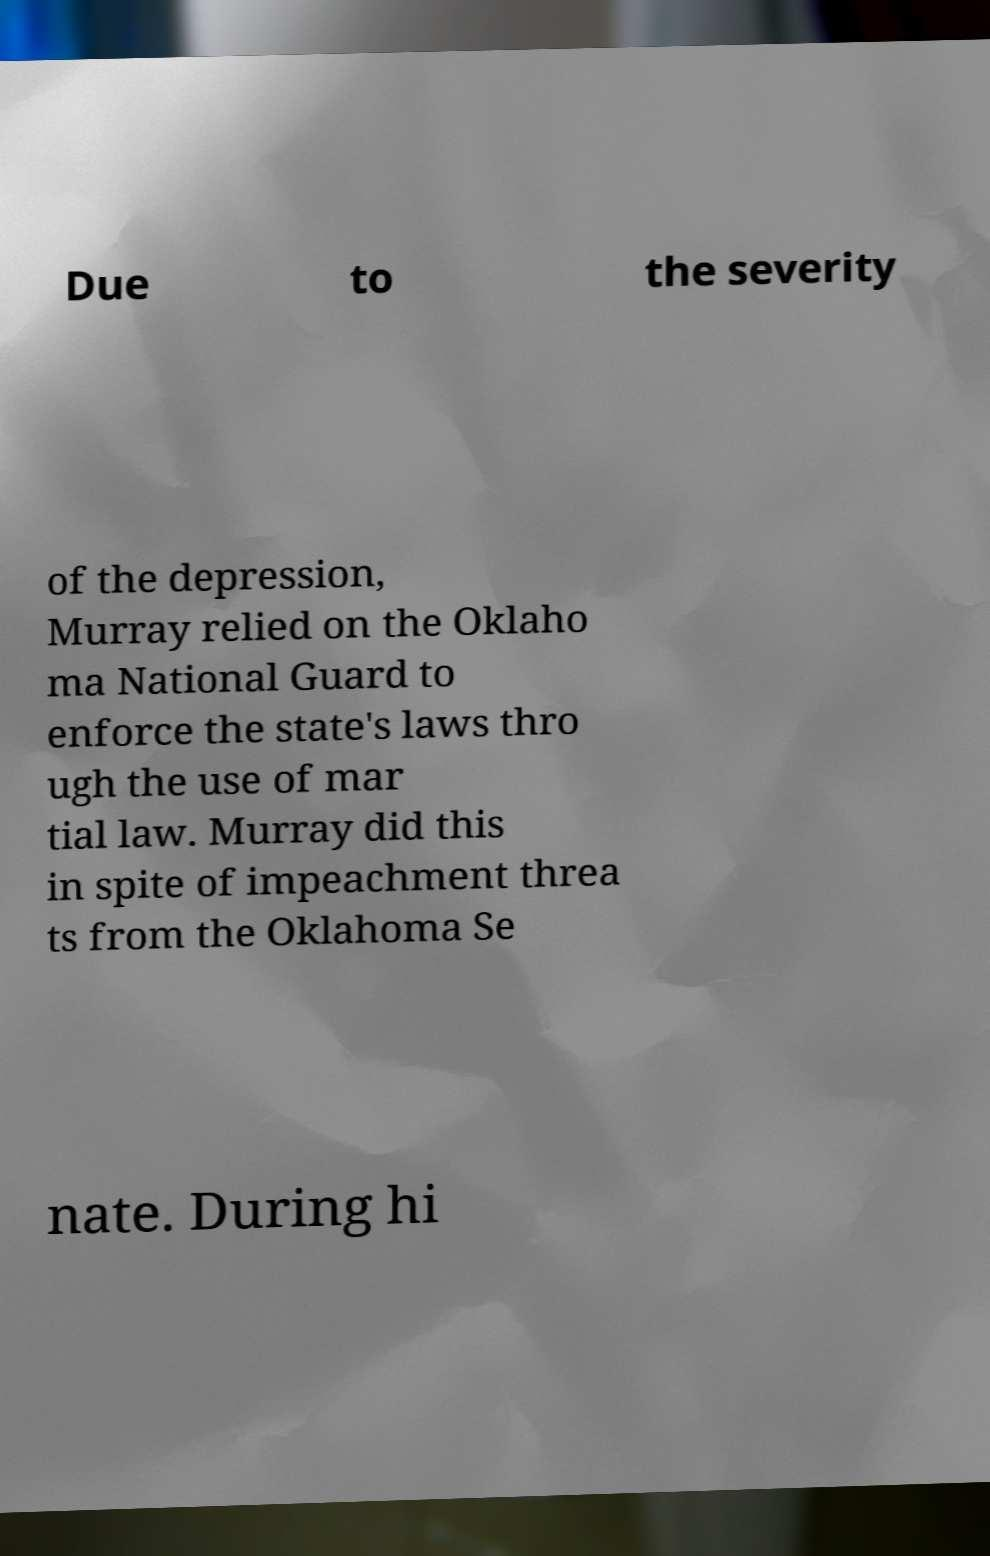Can you accurately transcribe the text from the provided image for me? Due to the severity of the depression, Murray relied on the Oklaho ma National Guard to enforce the state's laws thro ugh the use of mar tial law. Murray did this in spite of impeachment threa ts from the Oklahoma Se nate. During hi 